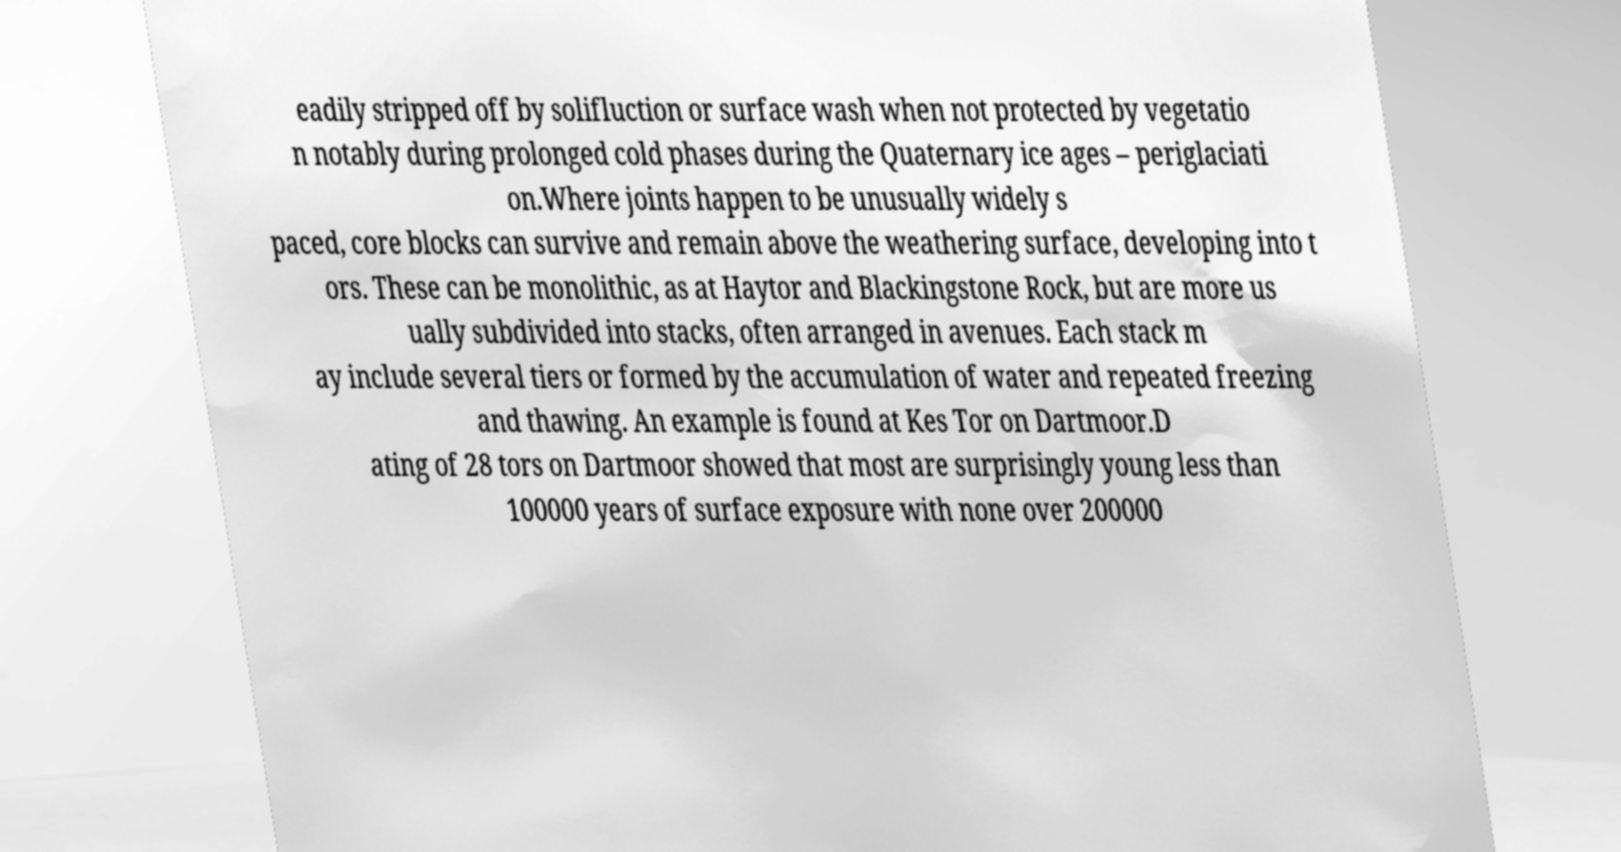Please read and relay the text visible in this image. What does it say? eadily stripped off by solifluction or surface wash when not protected by vegetatio n notably during prolonged cold phases during the Quaternary ice ages – periglaciati on.Where joints happen to be unusually widely s paced, core blocks can survive and remain above the weathering surface, developing into t ors. These can be monolithic, as at Haytor and Blackingstone Rock, but are more us ually subdivided into stacks, often arranged in avenues. Each stack m ay include several tiers or formed by the accumulation of water and repeated freezing and thawing. An example is found at Kes Tor on Dartmoor.D ating of 28 tors on Dartmoor showed that most are surprisingly young less than 100000 years of surface exposure with none over 200000 